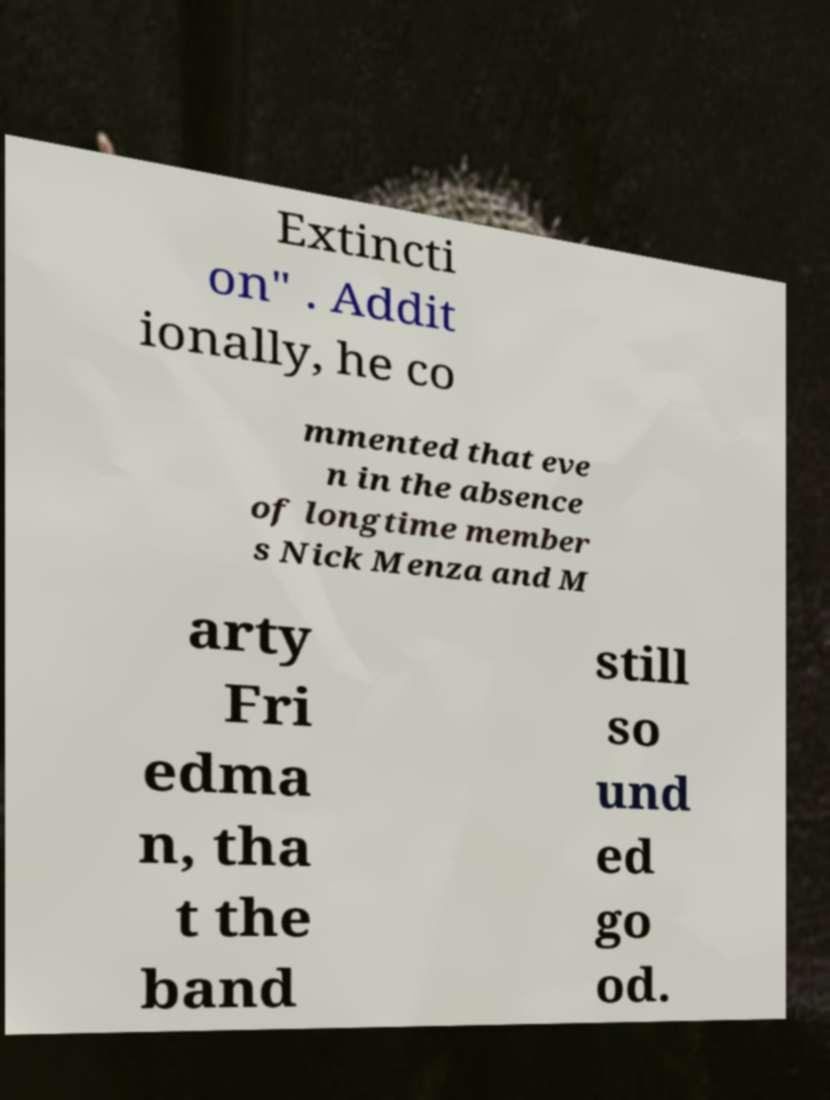Could you extract and type out the text from this image? Extincti on" . Addit ionally, he co mmented that eve n in the absence of longtime member s Nick Menza and M arty Fri edma n, tha t the band still so und ed go od. 